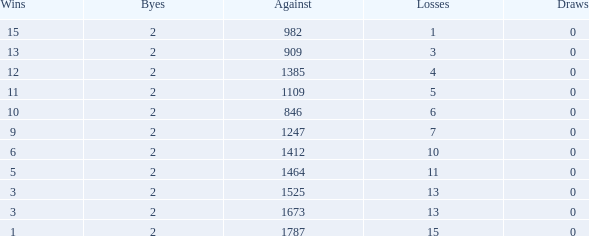What is the average number of Byes when there were less than 0 losses and were against 1247? None. Give me the full table as a dictionary. {'header': ['Wins', 'Byes', 'Against', 'Losses', 'Draws'], 'rows': [['15', '2', '982', '1', '0'], ['13', '2', '909', '3', '0'], ['12', '2', '1385', '4', '0'], ['11', '2', '1109', '5', '0'], ['10', '2', '846', '6', '0'], ['9', '2', '1247', '7', '0'], ['6', '2', '1412', '10', '0'], ['5', '2', '1464', '11', '0'], ['3', '2', '1525', '13', '0'], ['3', '2', '1673', '13', '0'], ['1', '2', '1787', '15', '0']]} 